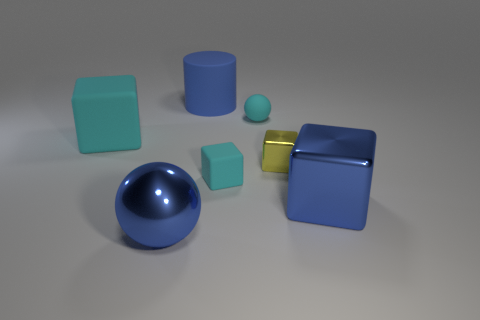Subtract all small yellow blocks. How many blocks are left? 3 Add 2 large blue rubber objects. How many objects exist? 9 Subtract all balls. How many objects are left? 5 Subtract all gray spheres. How many cyan cubes are left? 2 Subtract all purple spheres. Subtract all blue cylinders. How many spheres are left? 2 Subtract all yellow shiny things. Subtract all tiny matte things. How many objects are left? 4 Add 4 cyan rubber spheres. How many cyan rubber spheres are left? 5 Add 4 tiny cyan cubes. How many tiny cyan cubes exist? 5 Subtract all cyan spheres. How many spheres are left? 1 Subtract 0 gray blocks. How many objects are left? 7 